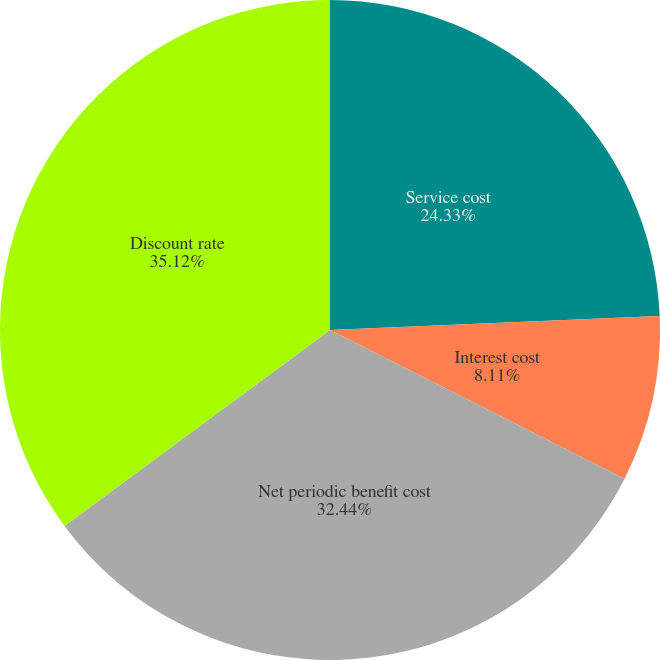Convert chart to OTSL. <chart><loc_0><loc_0><loc_500><loc_500><pie_chart><fcel>Service cost<fcel>Interest cost<fcel>Net periodic benefit cost<fcel>Discount rate<nl><fcel>24.33%<fcel>8.11%<fcel>32.44%<fcel>35.12%<nl></chart> 